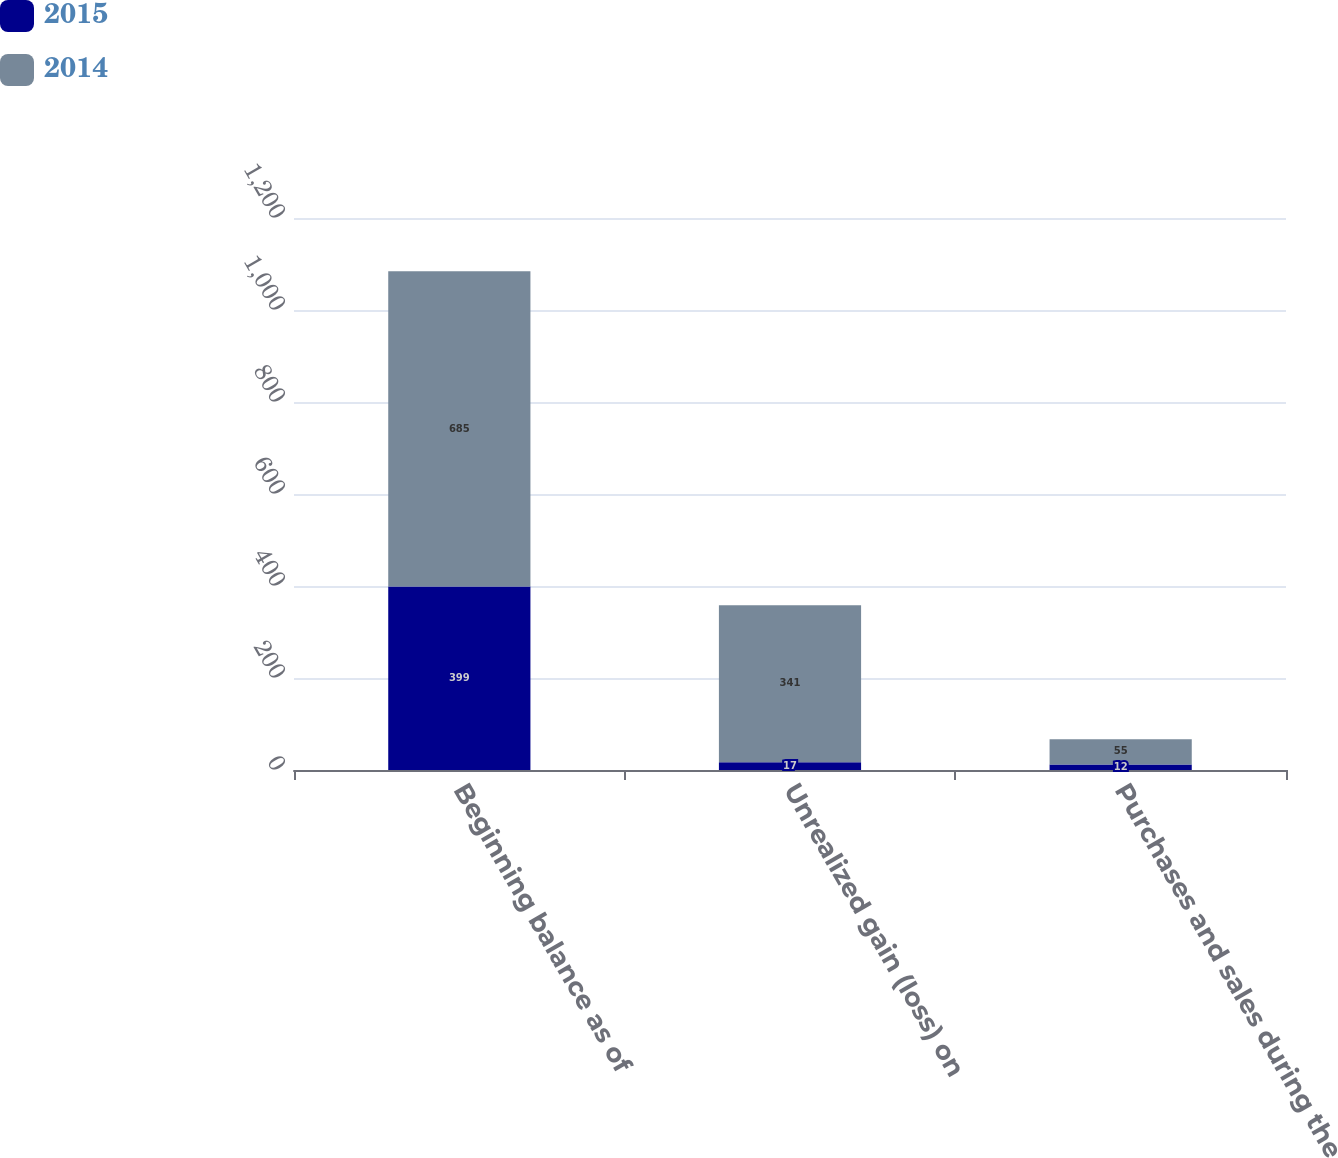<chart> <loc_0><loc_0><loc_500><loc_500><stacked_bar_chart><ecel><fcel>Beginning balance as of<fcel>Unrealized gain (loss) on<fcel>Purchases and sales during the<nl><fcel>2015<fcel>399<fcel>17<fcel>12<nl><fcel>2014<fcel>685<fcel>341<fcel>55<nl></chart> 